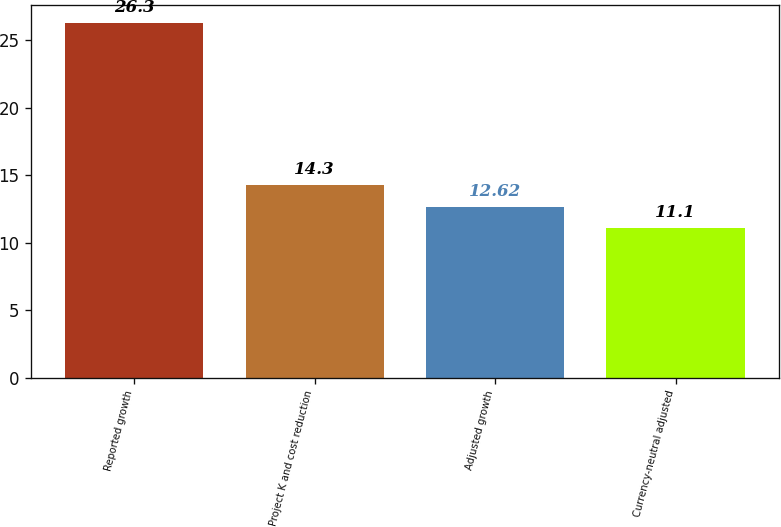Convert chart. <chart><loc_0><loc_0><loc_500><loc_500><bar_chart><fcel>Reported growth<fcel>Project K and cost reduction<fcel>Adjusted growth<fcel>Currency-neutral adjusted<nl><fcel>26.3<fcel>14.3<fcel>12.62<fcel>11.1<nl></chart> 